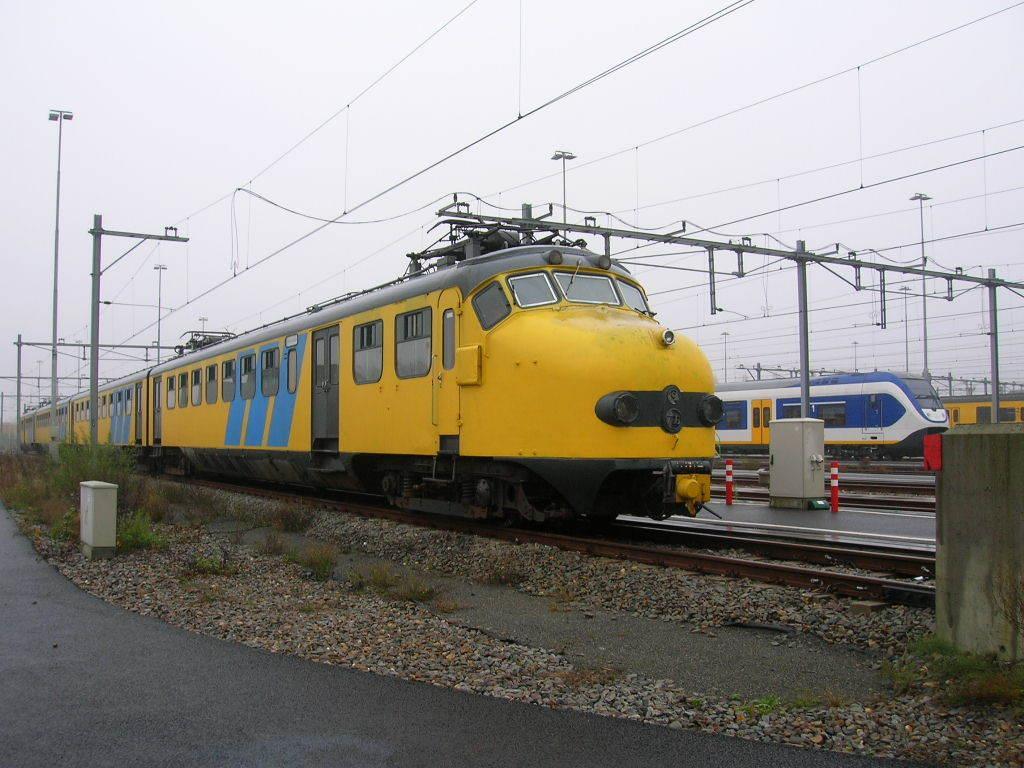In one or two sentences, can you explain what this image depicts? In the picture I can see trains on railway tracks. In the background I can see poles which has wires attached to them, the sky, plants and some other objects. 